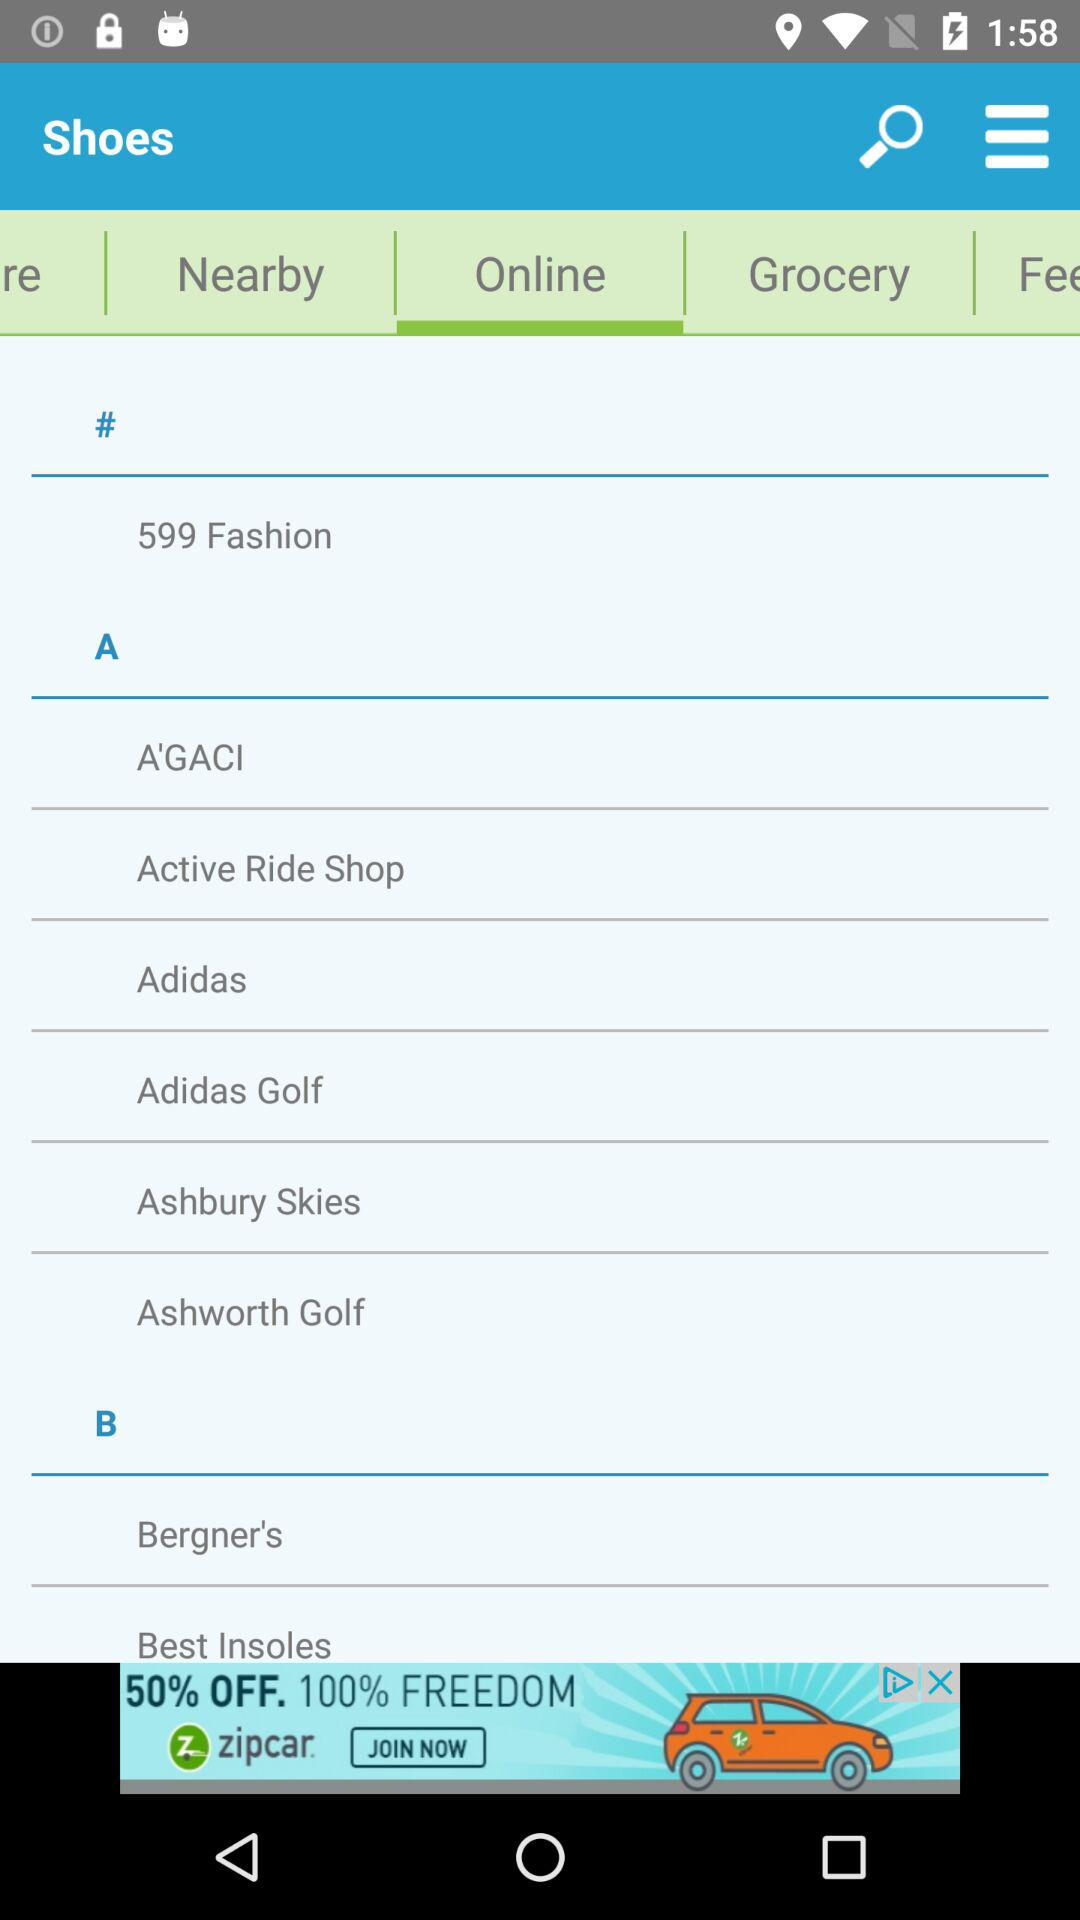What is the selected tab? The selected tab is "Online". 